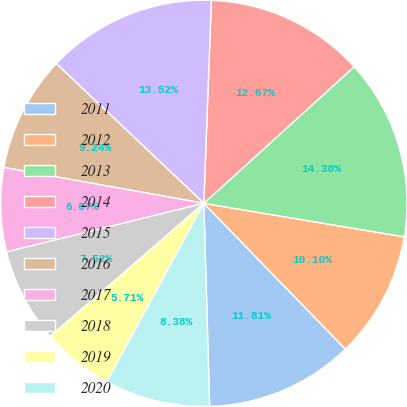<chart> <loc_0><loc_0><loc_500><loc_500><pie_chart><fcel>2011<fcel>2012<fcel>2013<fcel>2014<fcel>2015<fcel>2016<fcel>2017<fcel>2018<fcel>2019<fcel>2020<nl><fcel>11.81%<fcel>10.1%<fcel>14.38%<fcel>12.67%<fcel>13.52%<fcel>9.24%<fcel>6.67%<fcel>7.52%<fcel>5.71%<fcel>8.38%<nl></chart> 